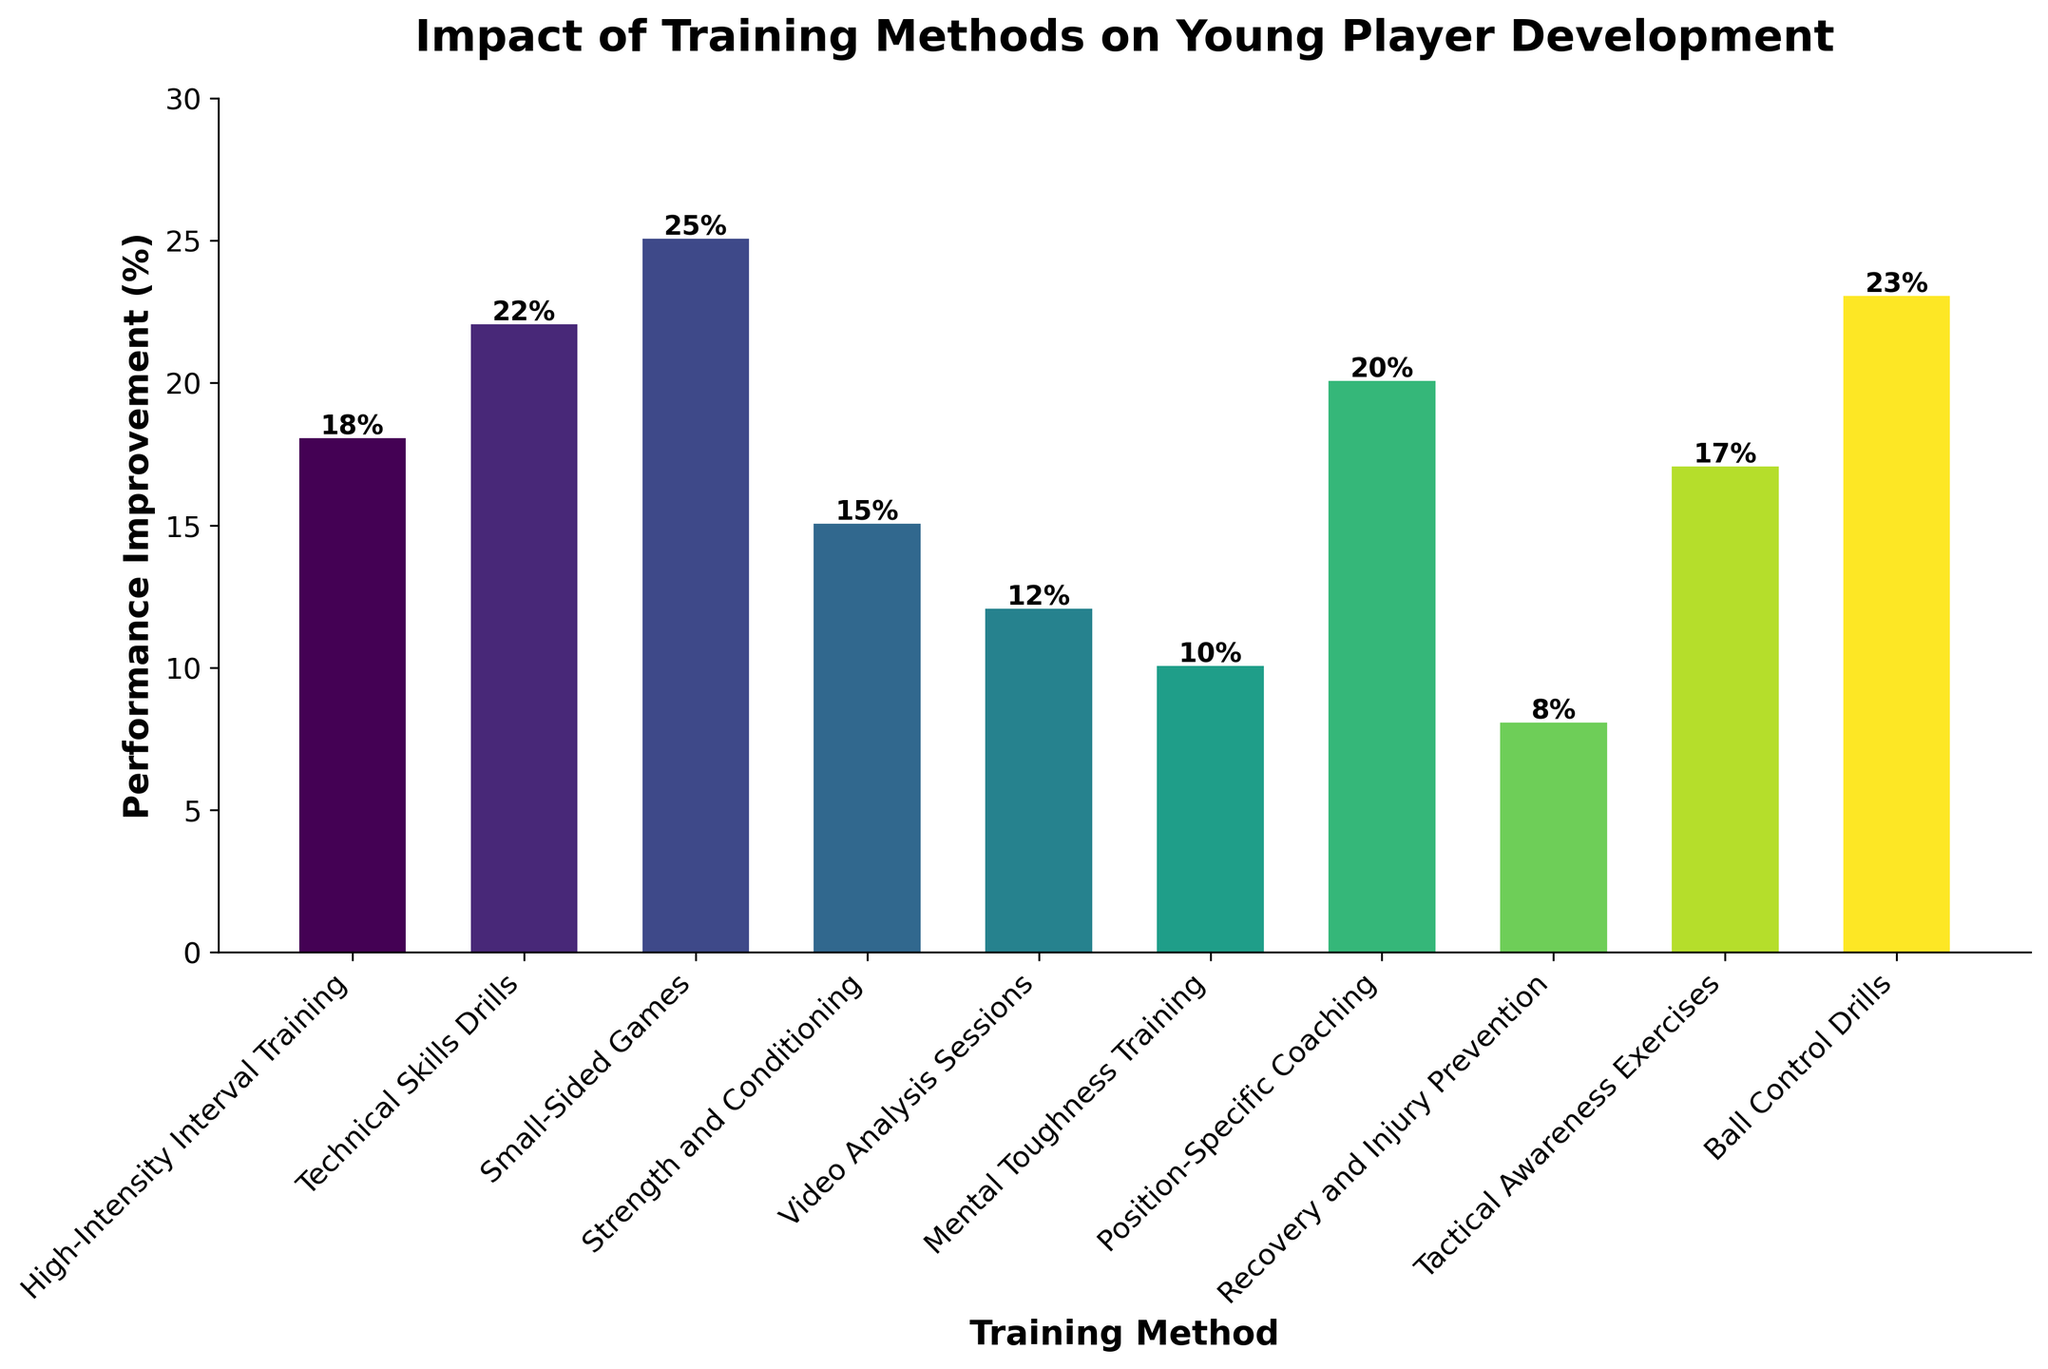What training method has the highest performance improvement based on the figure? Identify the bar with the greatest height. The highest bar corresponds to Small-Sided Games with 25%.
Answer: Small-Sided Games Which training method shows the lowest performance improvement? Identify the shortest bar. The lowest bar corresponds to Recovery and Injury Prevention with 8%.
Answer: Recovery and Injury Prevention What is the difference in performance improvement between Technical Skills Drills and Video Analysis Sessions? Subtract the performance improvement of Video Analysis Sessions (12%) from Technical Skills Drills (22%): 22% - 12% = 10%.
Answer: 10% What is the average performance improvement across all training methods? Sum all the improvement percentages and divide by the number of methods (10). \( \frac{18+22+25+15+12+10+20+8+17+23}{10} = \frac{170}{10} = 17\% \).
Answer: 17% How does the performance improvement of Position-Specific Coaching compare to High-Intensity Interval Training? Compare the heights of their respective bars: Position-Specific Coaching (20%) is higher than High-Intensity Interval Training (18%).
Answer: Position-Specific Coaching Which three training methods have the highest performance improvements, and what are their values? Find the bars with the three greatest heights: Small-Sided Games (25%), Ball Control Drills (23%), and Technical Skills Drills (22%).
Answer: Small-Sided Games (25%), Ball Control Drills (23%), Technical Skills Drills (22%) Is the performance improvement of Tactical Awareness Exercises higher or lower than the average improvement across all methods? Compare Tactical Awareness Exercises (17%) to the average improvement (17%).
Answer: Equal What is the total performance improvement of Mental Toughness Training and Recovery and Injury Prevention combined? Add the improvements of both methods: 10% + 8% = 18%.
Answer: 18% How much higher is the performance improvement of Ball Control Drills compared to Strength and Conditioning? Subtract the improvement of Strength and Conditioning (15%) from Ball Control Drills (23%): 23% - 15% = 8%.
Answer: 8% Which training methods have an improvement percentage above 20%? Identify bars taller than the 20% mark: Ball Control Drills (23%), Technical Skills Drills (22%), and Small-Sided Games (25%).
Answer: Ball Control Drills, Technical Skills Drills, Small-Sided Games 